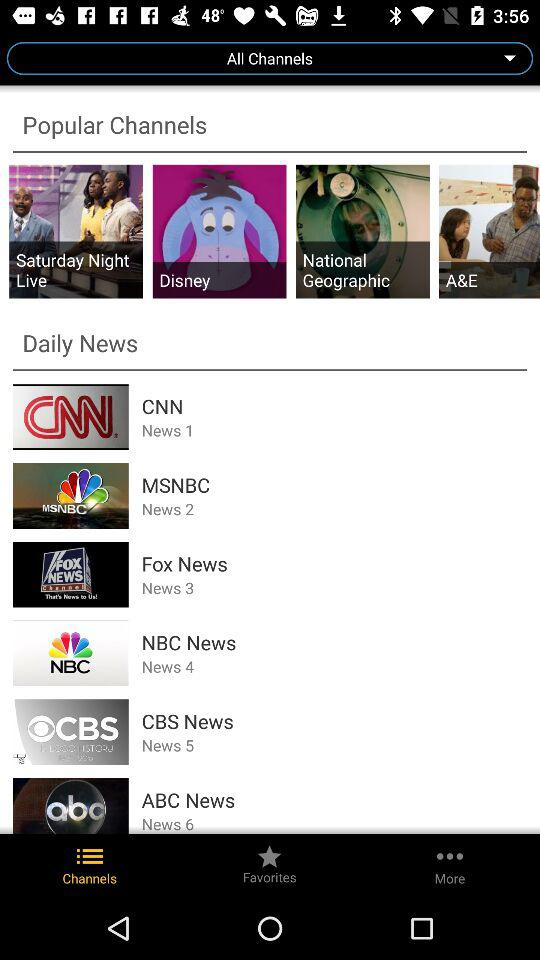Which tab is selected? The selected tab is "Channels". 